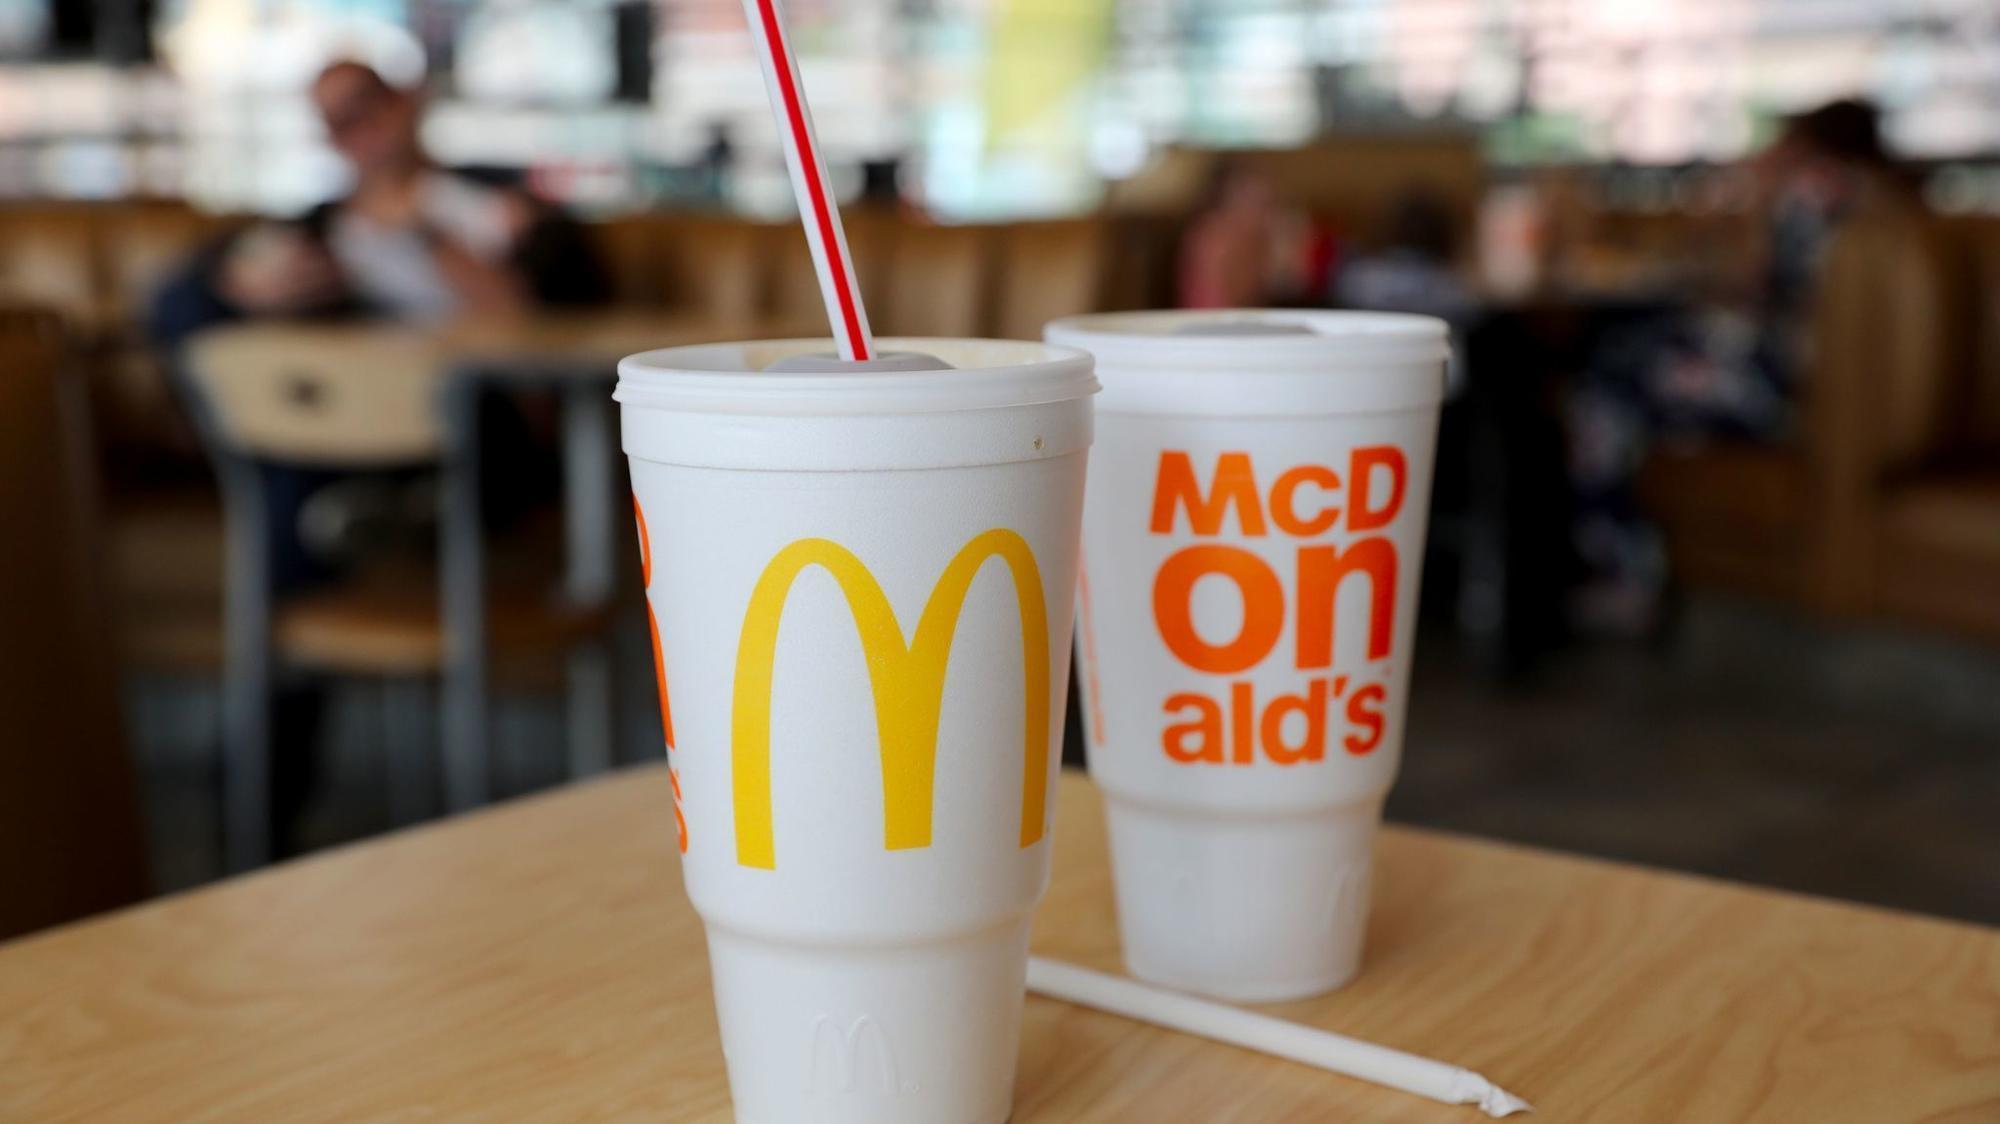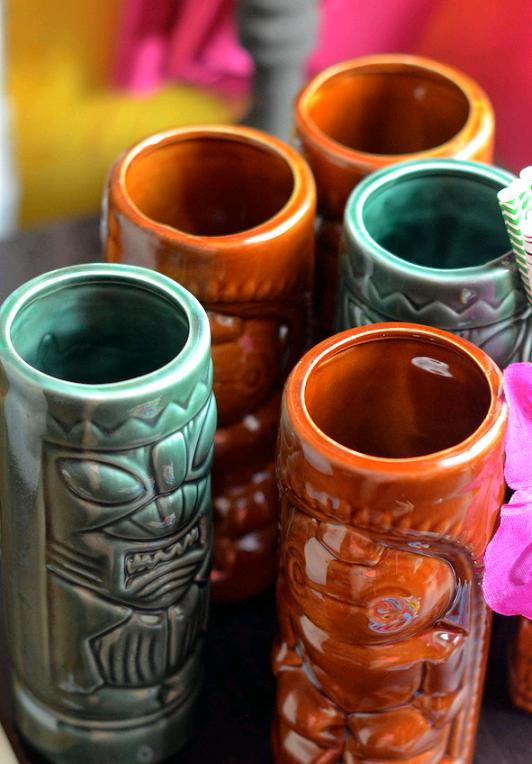The first image is the image on the left, the second image is the image on the right. For the images displayed, is the sentence "Some cups are made of plastic." factually correct? Answer yes or no. Yes. 